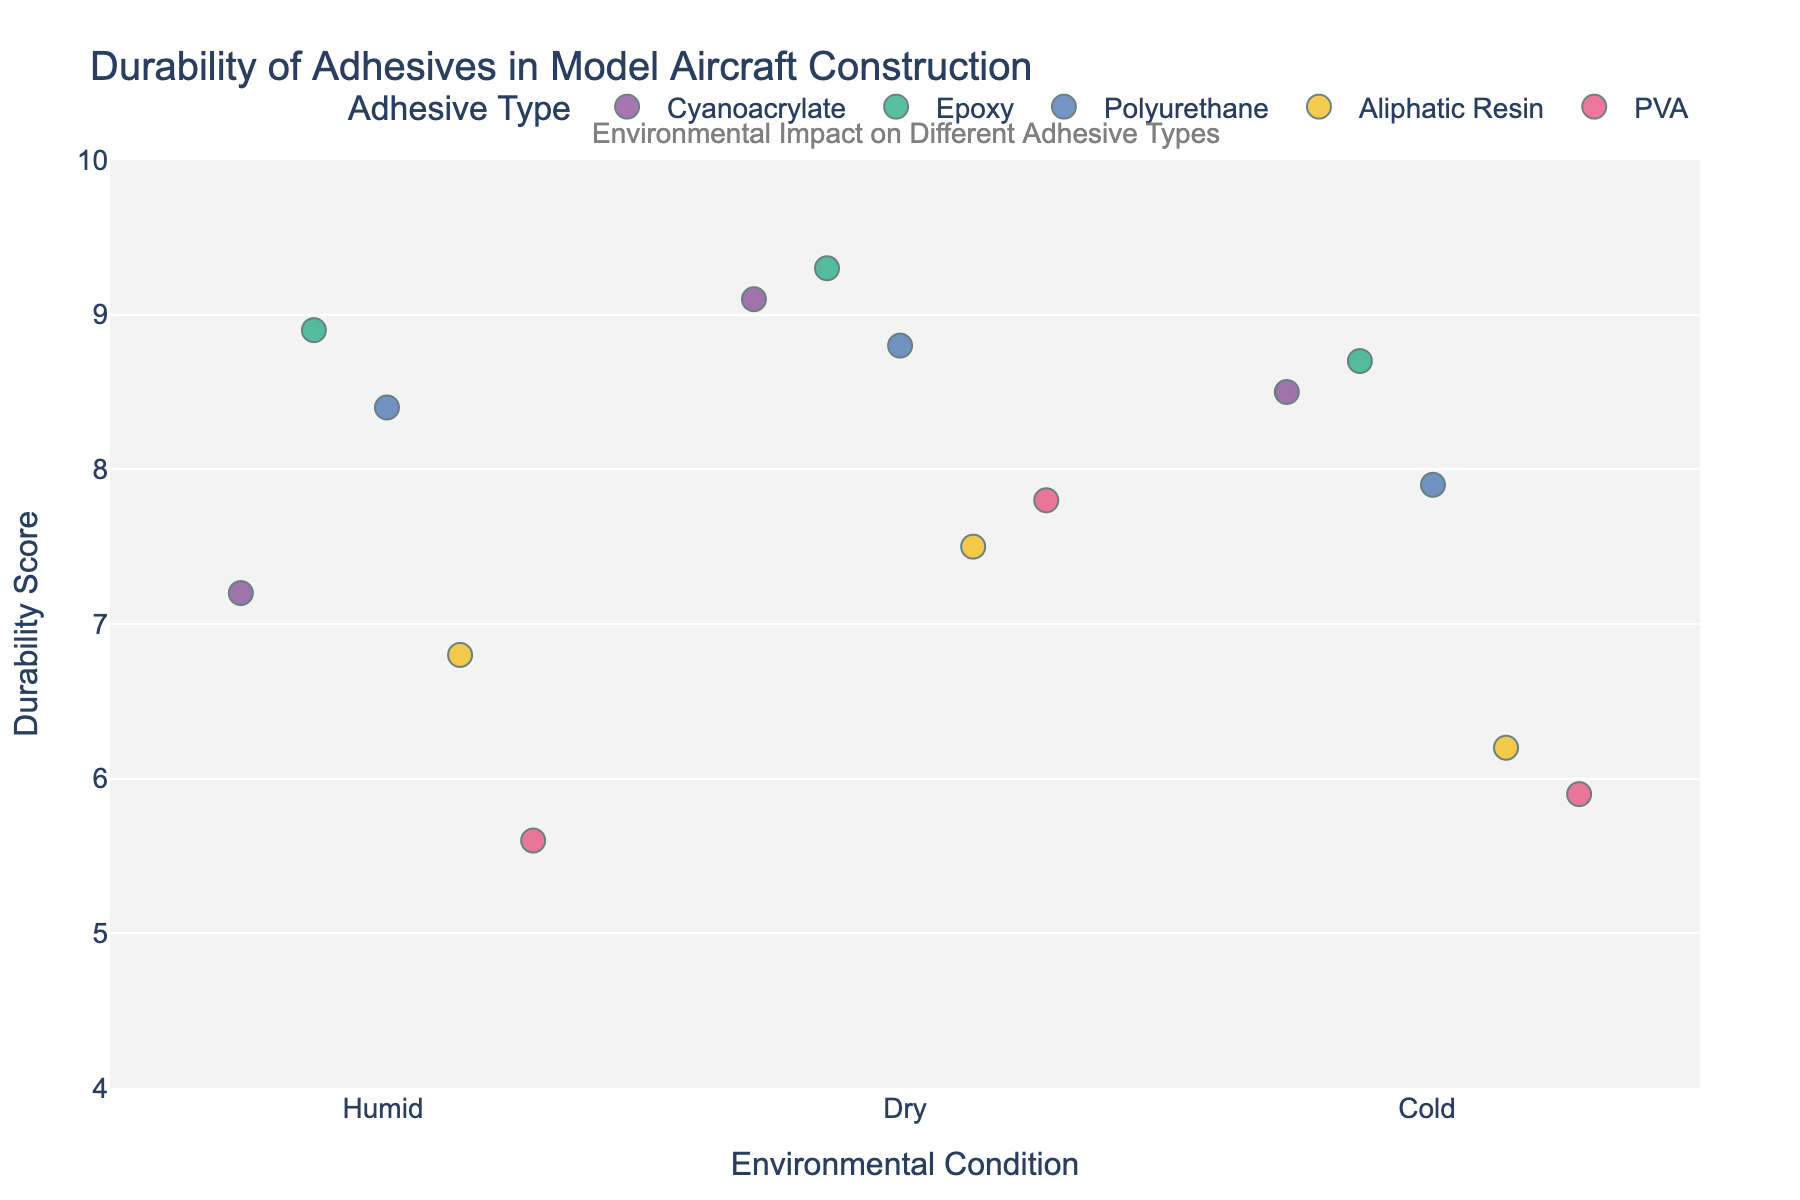What is the title of the figure? The title of the figure is displayed at the top and it reads "Durability of Adhesives in Model Aircraft Construction".
Answer: Durability of Adhesives in Model Aircraft Construction How many environmental conditions are shown in the plot? The x-axis of the plot lists the environmental conditions, and there are three unique conditions: "Humid", "Dry", and "Cold".
Answer: 3 Which adhesive shows the highest durability score in a dry environment? Looking at the points above the "Dry" label on the x-axis, the adhesive with the highest durability score is Epoxy, with a score of 9.3.
Answer: Epoxy Which adhesive has the lowest overall durability score in a humid environment? Observing the points above the "Humid" label on the x-axis, the adhesive with the lowest score is PVA with a score of 5.6.
Answer: PVA What is the median durability score of Polyurethane across all environmental conditions? For Polyurethane, the durability scores are 8.4 (Humid), 8.8 (Dry), and 7.9 (Cold). When ordered (7.9, 8.4, 8.8), the median is 8.4.
Answer: 8.4 How does the durability of Cyanoacrylate compare in humid vs. dry environments? Looking at the points for Cyanoacrylate, in a humid environment, its durability score is 7.2, and in a dry environment, its score is 9.1, showing it performs better in dry conditions.
Answer: It performs better in dry conditions Is there a significant difference in the durability score between Epoxy and Aliphatic Resin in humid conditions? Comparing the durability scores in humid conditions, Epoxy has a score of 8.9 and Aliphatic Resin has 6.8, showing a significant difference of 2.1 points.
Answer: Yes, a difference of 2.1 points Which adhesive shows the most consistent durability scores across different environments? Evaluating the range of durability scores for each adhesive, Epoxy shows scores of 8.9 (Humid), 9.3 (Dry), and 8.7 (Cold), making it the most consistent.
Answer: Epoxy What is the average durability score for Aliphatic Resin across all conditions? Aliphatic Resin durability scores are 6.8 (Humid), 7.5 (Dry), and 6.2 (Cold). The average is (6.8 + 7.5 + 6.2) / 3 = 6.833.
Answer: 6.83 